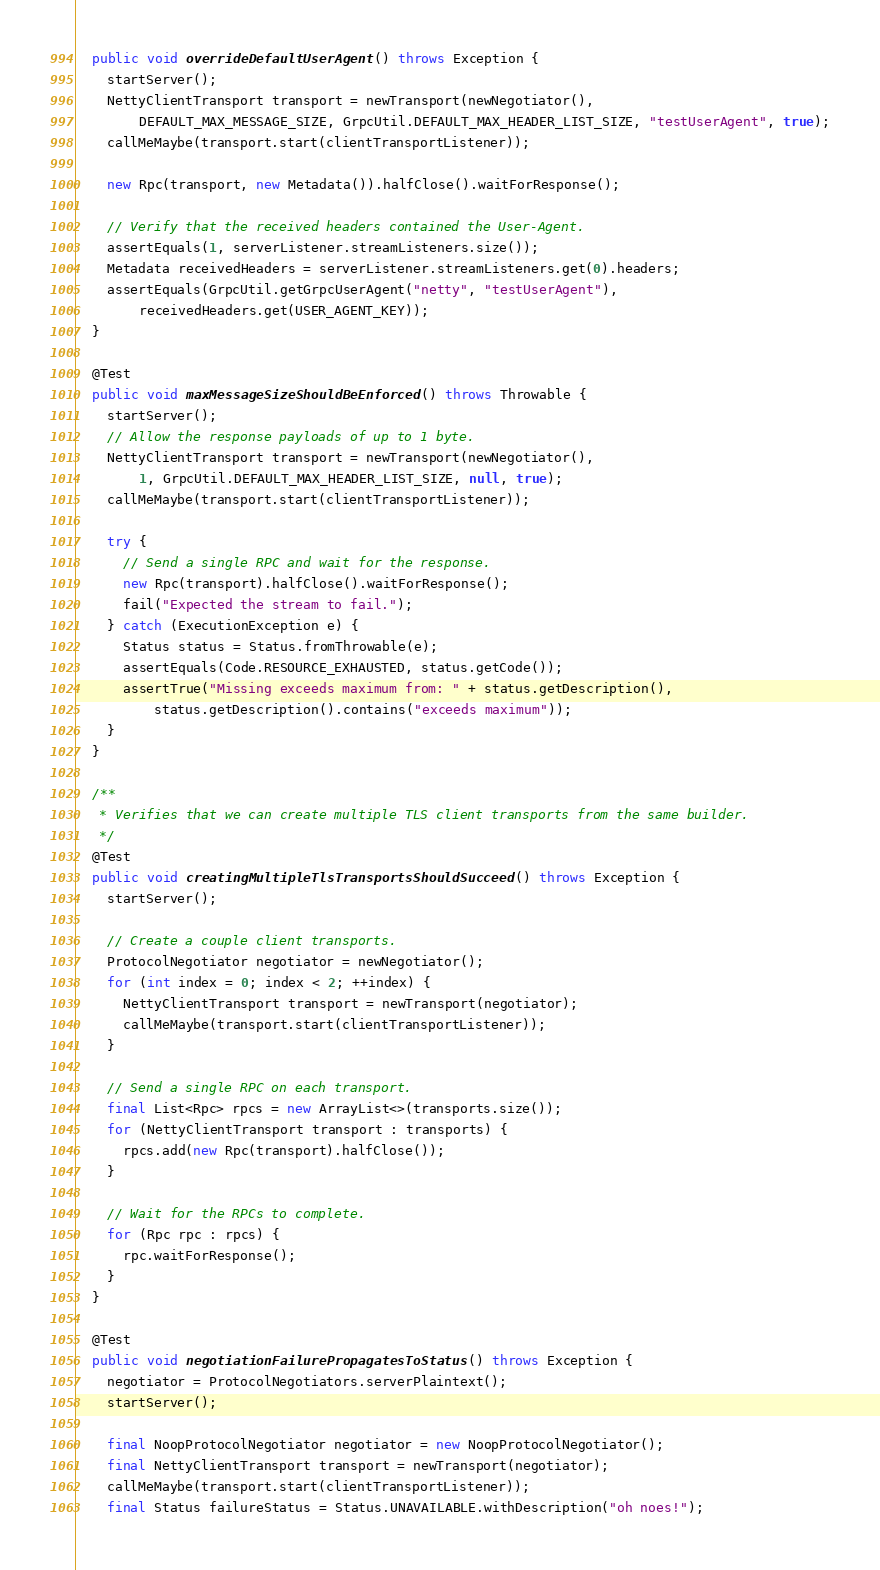<code> <loc_0><loc_0><loc_500><loc_500><_Java_>  public void overrideDefaultUserAgent() throws Exception {
    startServer();
    NettyClientTransport transport = newTransport(newNegotiator(),
        DEFAULT_MAX_MESSAGE_SIZE, GrpcUtil.DEFAULT_MAX_HEADER_LIST_SIZE, "testUserAgent", true);
    callMeMaybe(transport.start(clientTransportListener));

    new Rpc(transport, new Metadata()).halfClose().waitForResponse();

    // Verify that the received headers contained the User-Agent.
    assertEquals(1, serverListener.streamListeners.size());
    Metadata receivedHeaders = serverListener.streamListeners.get(0).headers;
    assertEquals(GrpcUtil.getGrpcUserAgent("netty", "testUserAgent"),
        receivedHeaders.get(USER_AGENT_KEY));
  }

  @Test
  public void maxMessageSizeShouldBeEnforced() throws Throwable {
    startServer();
    // Allow the response payloads of up to 1 byte.
    NettyClientTransport transport = newTransport(newNegotiator(),
        1, GrpcUtil.DEFAULT_MAX_HEADER_LIST_SIZE, null, true);
    callMeMaybe(transport.start(clientTransportListener));

    try {
      // Send a single RPC and wait for the response.
      new Rpc(transport).halfClose().waitForResponse();
      fail("Expected the stream to fail.");
    } catch (ExecutionException e) {
      Status status = Status.fromThrowable(e);
      assertEquals(Code.RESOURCE_EXHAUSTED, status.getCode());
      assertTrue("Missing exceeds maximum from: " + status.getDescription(),
          status.getDescription().contains("exceeds maximum"));
    }
  }

  /**
   * Verifies that we can create multiple TLS client transports from the same builder.
   */
  @Test
  public void creatingMultipleTlsTransportsShouldSucceed() throws Exception {
    startServer();

    // Create a couple client transports.
    ProtocolNegotiator negotiator = newNegotiator();
    for (int index = 0; index < 2; ++index) {
      NettyClientTransport transport = newTransport(negotiator);
      callMeMaybe(transport.start(clientTransportListener));
    }

    // Send a single RPC on each transport.
    final List<Rpc> rpcs = new ArrayList<>(transports.size());
    for (NettyClientTransport transport : transports) {
      rpcs.add(new Rpc(transport).halfClose());
    }

    // Wait for the RPCs to complete.
    for (Rpc rpc : rpcs) {
      rpc.waitForResponse();
    }
  }

  @Test
  public void negotiationFailurePropagatesToStatus() throws Exception {
    negotiator = ProtocolNegotiators.serverPlaintext();
    startServer();

    final NoopProtocolNegotiator negotiator = new NoopProtocolNegotiator();
    final NettyClientTransport transport = newTransport(negotiator);
    callMeMaybe(transport.start(clientTransportListener));
    final Status failureStatus = Status.UNAVAILABLE.withDescription("oh noes!");</code> 